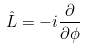<formula> <loc_0><loc_0><loc_500><loc_500>\hat { L } = - i \frac { \partial } { \partial \phi }</formula> 